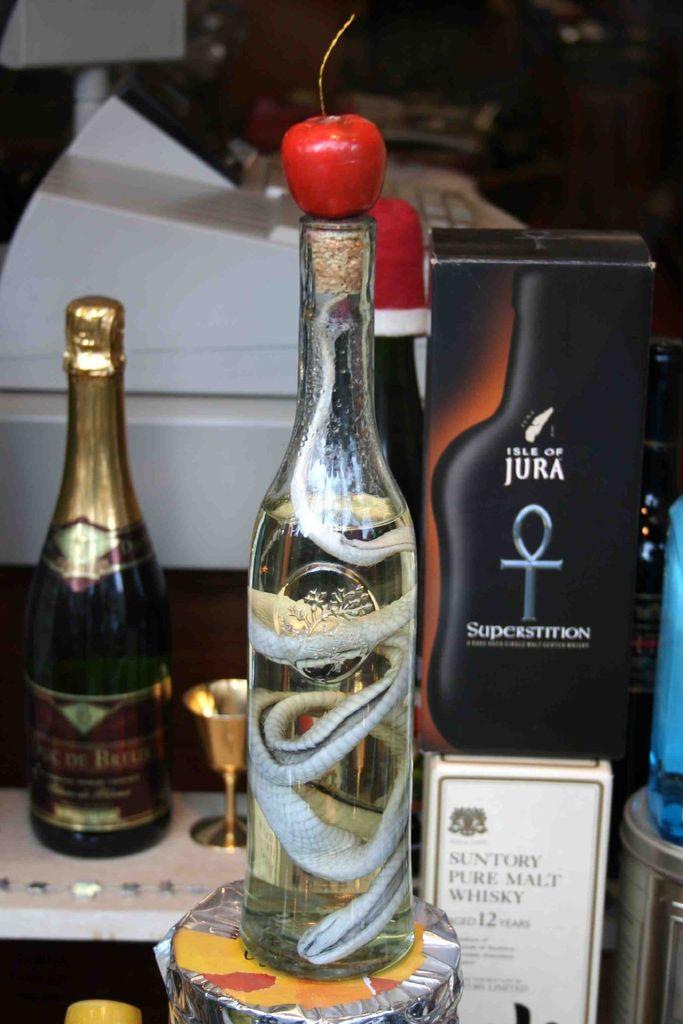Who makes the whisky in the white box?
Your answer should be compact. Suntory. 